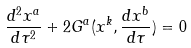Convert formula to latex. <formula><loc_0><loc_0><loc_500><loc_500>\frac { d ^ { 2 } x ^ { a } } { d \tau ^ { 2 } } + 2 G ^ { a } ( x ^ { k } , \frac { d x ^ { b } } { d \tau } ) = 0</formula> 